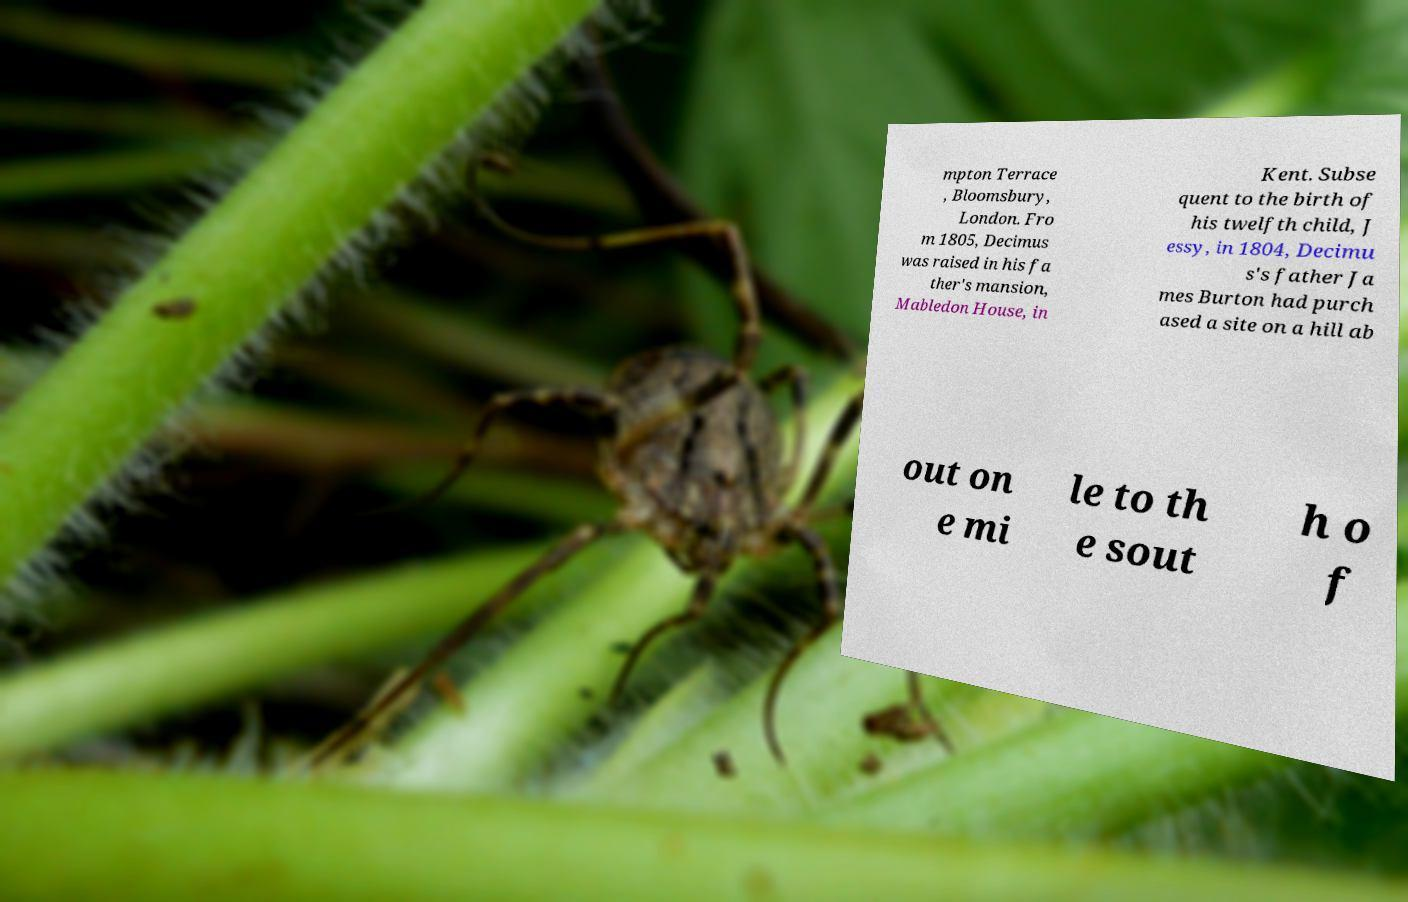Can you accurately transcribe the text from the provided image for me? mpton Terrace , Bloomsbury, London. Fro m 1805, Decimus was raised in his fa ther's mansion, Mabledon House, in Kent. Subse quent to the birth of his twelfth child, J essy, in 1804, Decimu s's father Ja mes Burton had purch ased a site on a hill ab out on e mi le to th e sout h o f 